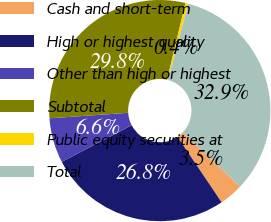<chart> <loc_0><loc_0><loc_500><loc_500><pie_chart><fcel>Cash and short-term<fcel>High or highest quality<fcel>Other than high or highest<fcel>Subtotal<fcel>Public equity securities at<fcel>Total<nl><fcel>3.5%<fcel>26.77%<fcel>6.56%<fcel>29.84%<fcel>0.43%<fcel>32.91%<nl></chart> 